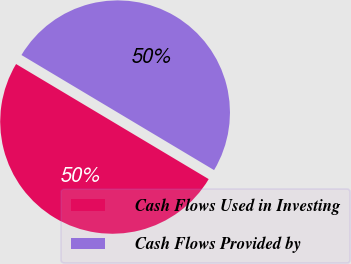<chart> <loc_0><loc_0><loc_500><loc_500><pie_chart><fcel>Cash Flows Used in Investing<fcel>Cash Flows Provided by<nl><fcel>50.0%<fcel>50.0%<nl></chart> 